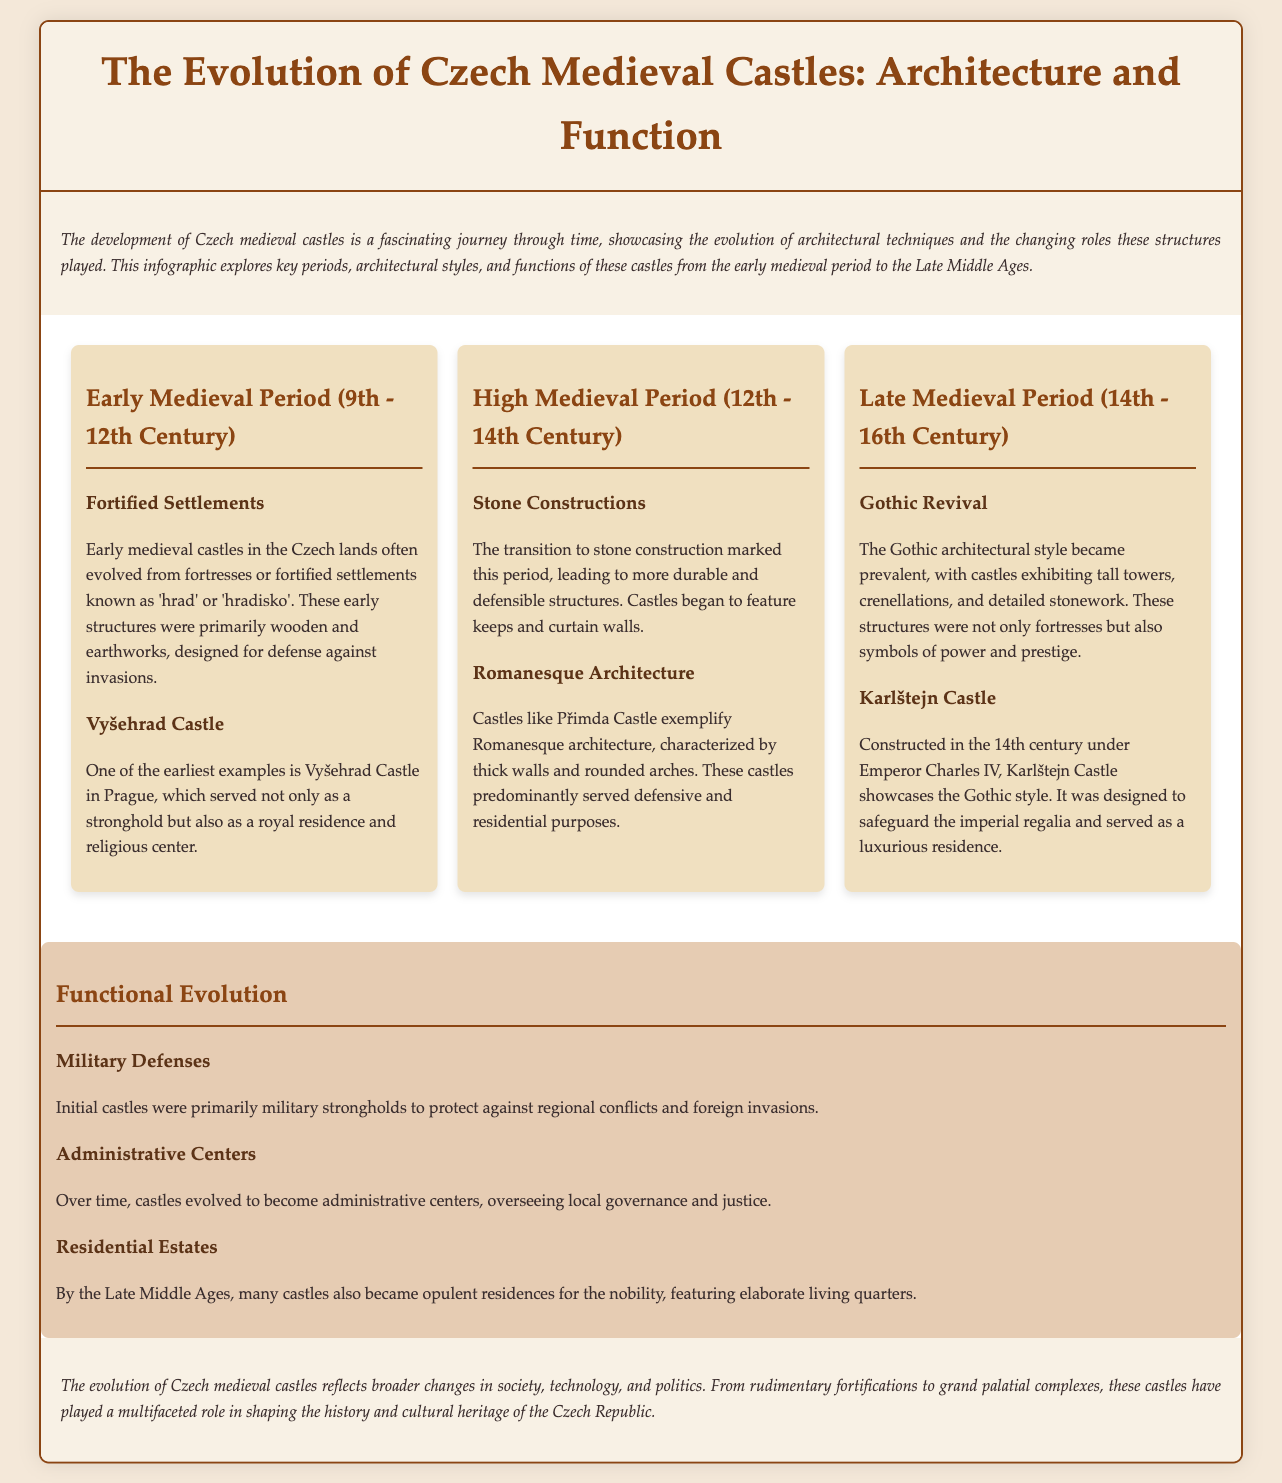What is the earliest period of Czech medieval castles? The document mentions the Early Medieval Period as the first period of Czech medieval castles, covering the 9th to 12th century.
Answer: Early Medieval Period (9th - 12th Century) Which castle is an example from the Early Medieval Period? Vyšehrad Castle is specifically mentioned as one of the earliest examples from this period.
Answer: Vyšehrad Castle What architectural style dominated the High Medieval Period? The document states that stone constructions marked the High Medieval Period, leading to durable structures.
Answer: Stone Constructions Which castle showcases Gothic architecture? The document specifically cites Karlštejn Castle as an example of Gothic architectural style.
Answer: Karlštejn Castle What was the primary function of initial medieval castles? The document indicates that the initial castles served primarily as military defenses against invasions.
Answer: Military Defenses How did the function of castles evolve over time? The document discusses the transition of castles from military strongholds to administrative centers and luxury residences.
Answer: Administrative Centers What prominent feature became common in castles during the Late Medieval Period? Castle design in the Late Medieval Period often included tall towers and crenellations, as noted in the document.
Answer: Tall towers and crenellations How many periods are detailed in the document? The document outlines three distinct periods of Czech medieval castles.
Answer: Three What is the primary focus of the infographic? The infographic explores the evolution of architecture and function of Czech medieval castles through different periods.
Answer: Architecture and Function 